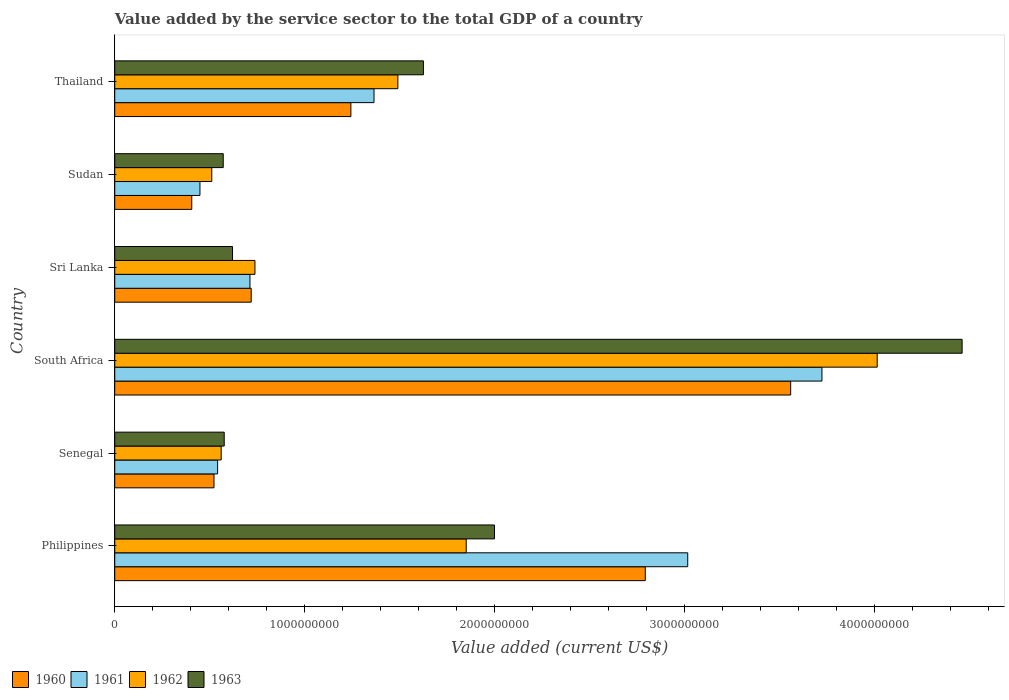Are the number of bars on each tick of the Y-axis equal?
Your answer should be very brief. Yes. How many bars are there on the 6th tick from the bottom?
Provide a short and direct response. 4. What is the value added by the service sector to the total GDP in 1962 in Philippines?
Ensure brevity in your answer.  1.85e+09. Across all countries, what is the maximum value added by the service sector to the total GDP in 1960?
Give a very brief answer. 3.56e+09. Across all countries, what is the minimum value added by the service sector to the total GDP in 1960?
Your answer should be compact. 4.06e+08. In which country was the value added by the service sector to the total GDP in 1962 maximum?
Provide a succinct answer. South Africa. In which country was the value added by the service sector to the total GDP in 1961 minimum?
Make the answer very short. Sudan. What is the total value added by the service sector to the total GDP in 1962 in the graph?
Offer a terse response. 9.17e+09. What is the difference between the value added by the service sector to the total GDP in 1960 in Philippines and that in Sri Lanka?
Ensure brevity in your answer.  2.08e+09. What is the difference between the value added by the service sector to the total GDP in 1962 in South Africa and the value added by the service sector to the total GDP in 1961 in Senegal?
Offer a very short reply. 3.47e+09. What is the average value added by the service sector to the total GDP in 1960 per country?
Keep it short and to the point. 1.54e+09. What is the difference between the value added by the service sector to the total GDP in 1961 and value added by the service sector to the total GDP in 1960 in South Africa?
Provide a short and direct response. 1.65e+08. In how many countries, is the value added by the service sector to the total GDP in 1963 greater than 200000000 US$?
Keep it short and to the point. 6. What is the ratio of the value added by the service sector to the total GDP in 1960 in Philippines to that in Sri Lanka?
Offer a very short reply. 3.89. Is the value added by the service sector to the total GDP in 1960 in South Africa less than that in Sri Lanka?
Offer a very short reply. No. Is the difference between the value added by the service sector to the total GDP in 1961 in South Africa and Sri Lanka greater than the difference between the value added by the service sector to the total GDP in 1960 in South Africa and Sri Lanka?
Offer a very short reply. Yes. What is the difference between the highest and the second highest value added by the service sector to the total GDP in 1963?
Keep it short and to the point. 2.46e+09. What is the difference between the highest and the lowest value added by the service sector to the total GDP in 1962?
Provide a succinct answer. 3.50e+09. In how many countries, is the value added by the service sector to the total GDP in 1960 greater than the average value added by the service sector to the total GDP in 1960 taken over all countries?
Ensure brevity in your answer.  2. How many legend labels are there?
Make the answer very short. 4. What is the title of the graph?
Your answer should be very brief. Value added by the service sector to the total GDP of a country. Does "1974" appear as one of the legend labels in the graph?
Provide a succinct answer. No. What is the label or title of the X-axis?
Your answer should be compact. Value added (current US$). What is the label or title of the Y-axis?
Offer a very short reply. Country. What is the Value added (current US$) in 1960 in Philippines?
Your answer should be compact. 2.79e+09. What is the Value added (current US$) of 1961 in Philippines?
Make the answer very short. 3.02e+09. What is the Value added (current US$) in 1962 in Philippines?
Your response must be concise. 1.85e+09. What is the Value added (current US$) in 1963 in Philippines?
Make the answer very short. 2.00e+09. What is the Value added (current US$) in 1960 in Senegal?
Your response must be concise. 5.23e+08. What is the Value added (current US$) of 1961 in Senegal?
Offer a terse response. 5.42e+08. What is the Value added (current US$) in 1962 in Senegal?
Your answer should be very brief. 5.60e+08. What is the Value added (current US$) in 1963 in Senegal?
Provide a short and direct response. 5.76e+08. What is the Value added (current US$) of 1960 in South Africa?
Ensure brevity in your answer.  3.56e+09. What is the Value added (current US$) in 1961 in South Africa?
Provide a succinct answer. 3.72e+09. What is the Value added (current US$) of 1962 in South Africa?
Offer a very short reply. 4.01e+09. What is the Value added (current US$) of 1963 in South Africa?
Keep it short and to the point. 4.46e+09. What is the Value added (current US$) in 1960 in Sri Lanka?
Your response must be concise. 7.18e+08. What is the Value added (current US$) in 1961 in Sri Lanka?
Your answer should be very brief. 7.12e+08. What is the Value added (current US$) in 1962 in Sri Lanka?
Keep it short and to the point. 7.38e+08. What is the Value added (current US$) of 1963 in Sri Lanka?
Your answer should be compact. 6.20e+08. What is the Value added (current US$) in 1960 in Sudan?
Offer a terse response. 4.06e+08. What is the Value added (current US$) in 1961 in Sudan?
Offer a terse response. 4.49e+08. What is the Value added (current US$) in 1962 in Sudan?
Your response must be concise. 5.11e+08. What is the Value added (current US$) in 1963 in Sudan?
Offer a terse response. 5.71e+08. What is the Value added (current US$) in 1960 in Thailand?
Ensure brevity in your answer.  1.24e+09. What is the Value added (current US$) in 1961 in Thailand?
Your response must be concise. 1.37e+09. What is the Value added (current US$) of 1962 in Thailand?
Provide a short and direct response. 1.49e+09. What is the Value added (current US$) of 1963 in Thailand?
Your answer should be very brief. 1.63e+09. Across all countries, what is the maximum Value added (current US$) of 1960?
Your answer should be compact. 3.56e+09. Across all countries, what is the maximum Value added (current US$) in 1961?
Your answer should be very brief. 3.72e+09. Across all countries, what is the maximum Value added (current US$) of 1962?
Keep it short and to the point. 4.01e+09. Across all countries, what is the maximum Value added (current US$) in 1963?
Provide a short and direct response. 4.46e+09. Across all countries, what is the minimum Value added (current US$) in 1960?
Give a very brief answer. 4.06e+08. Across all countries, what is the minimum Value added (current US$) of 1961?
Keep it short and to the point. 4.49e+08. Across all countries, what is the minimum Value added (current US$) in 1962?
Keep it short and to the point. 5.11e+08. Across all countries, what is the minimum Value added (current US$) in 1963?
Offer a terse response. 5.71e+08. What is the total Value added (current US$) of 1960 in the graph?
Provide a succinct answer. 9.24e+09. What is the total Value added (current US$) in 1961 in the graph?
Your answer should be compact. 9.81e+09. What is the total Value added (current US$) of 1962 in the graph?
Offer a terse response. 9.17e+09. What is the total Value added (current US$) of 1963 in the graph?
Ensure brevity in your answer.  9.85e+09. What is the difference between the Value added (current US$) in 1960 in Philippines and that in Senegal?
Keep it short and to the point. 2.27e+09. What is the difference between the Value added (current US$) in 1961 in Philippines and that in Senegal?
Offer a very short reply. 2.48e+09. What is the difference between the Value added (current US$) in 1962 in Philippines and that in Senegal?
Your answer should be compact. 1.29e+09. What is the difference between the Value added (current US$) of 1963 in Philippines and that in Senegal?
Offer a terse response. 1.42e+09. What is the difference between the Value added (current US$) of 1960 in Philippines and that in South Africa?
Your response must be concise. -7.66e+08. What is the difference between the Value added (current US$) of 1961 in Philippines and that in South Africa?
Your answer should be compact. -7.07e+08. What is the difference between the Value added (current US$) of 1962 in Philippines and that in South Africa?
Your answer should be compact. -2.16e+09. What is the difference between the Value added (current US$) of 1963 in Philippines and that in South Africa?
Your answer should be very brief. -2.46e+09. What is the difference between the Value added (current US$) in 1960 in Philippines and that in Sri Lanka?
Offer a very short reply. 2.08e+09. What is the difference between the Value added (current US$) of 1961 in Philippines and that in Sri Lanka?
Offer a terse response. 2.31e+09. What is the difference between the Value added (current US$) of 1962 in Philippines and that in Sri Lanka?
Your answer should be very brief. 1.11e+09. What is the difference between the Value added (current US$) of 1963 in Philippines and that in Sri Lanka?
Your answer should be very brief. 1.38e+09. What is the difference between the Value added (current US$) in 1960 in Philippines and that in Sudan?
Provide a short and direct response. 2.39e+09. What is the difference between the Value added (current US$) in 1961 in Philippines and that in Sudan?
Your response must be concise. 2.57e+09. What is the difference between the Value added (current US$) of 1962 in Philippines and that in Sudan?
Offer a very short reply. 1.34e+09. What is the difference between the Value added (current US$) of 1963 in Philippines and that in Sudan?
Provide a succinct answer. 1.43e+09. What is the difference between the Value added (current US$) in 1960 in Philippines and that in Thailand?
Offer a terse response. 1.55e+09. What is the difference between the Value added (current US$) of 1961 in Philippines and that in Thailand?
Provide a short and direct response. 1.65e+09. What is the difference between the Value added (current US$) in 1962 in Philippines and that in Thailand?
Provide a succinct answer. 3.60e+08. What is the difference between the Value added (current US$) of 1963 in Philippines and that in Thailand?
Offer a very short reply. 3.74e+08. What is the difference between the Value added (current US$) in 1960 in Senegal and that in South Africa?
Provide a short and direct response. -3.04e+09. What is the difference between the Value added (current US$) in 1961 in Senegal and that in South Africa?
Make the answer very short. -3.18e+09. What is the difference between the Value added (current US$) in 1962 in Senegal and that in South Africa?
Offer a terse response. -3.45e+09. What is the difference between the Value added (current US$) of 1963 in Senegal and that in South Africa?
Your response must be concise. -3.89e+09. What is the difference between the Value added (current US$) in 1960 in Senegal and that in Sri Lanka?
Keep it short and to the point. -1.96e+08. What is the difference between the Value added (current US$) in 1961 in Senegal and that in Sri Lanka?
Give a very brief answer. -1.70e+08. What is the difference between the Value added (current US$) of 1962 in Senegal and that in Sri Lanka?
Offer a very short reply. -1.78e+08. What is the difference between the Value added (current US$) in 1963 in Senegal and that in Sri Lanka?
Give a very brief answer. -4.38e+07. What is the difference between the Value added (current US$) of 1960 in Senegal and that in Sudan?
Give a very brief answer. 1.17e+08. What is the difference between the Value added (current US$) of 1961 in Senegal and that in Sudan?
Provide a short and direct response. 9.30e+07. What is the difference between the Value added (current US$) of 1962 in Senegal and that in Sudan?
Make the answer very short. 4.95e+07. What is the difference between the Value added (current US$) of 1963 in Senegal and that in Sudan?
Provide a short and direct response. 5.17e+06. What is the difference between the Value added (current US$) of 1960 in Senegal and that in Thailand?
Your answer should be compact. -7.21e+08. What is the difference between the Value added (current US$) of 1961 in Senegal and that in Thailand?
Ensure brevity in your answer.  -8.24e+08. What is the difference between the Value added (current US$) in 1962 in Senegal and that in Thailand?
Ensure brevity in your answer.  -9.30e+08. What is the difference between the Value added (current US$) in 1963 in Senegal and that in Thailand?
Provide a succinct answer. -1.05e+09. What is the difference between the Value added (current US$) in 1960 in South Africa and that in Sri Lanka?
Provide a short and direct response. 2.84e+09. What is the difference between the Value added (current US$) in 1961 in South Africa and that in Sri Lanka?
Your answer should be compact. 3.01e+09. What is the difference between the Value added (current US$) in 1962 in South Africa and that in Sri Lanka?
Your response must be concise. 3.28e+09. What is the difference between the Value added (current US$) of 1963 in South Africa and that in Sri Lanka?
Your answer should be very brief. 3.84e+09. What is the difference between the Value added (current US$) of 1960 in South Africa and that in Sudan?
Ensure brevity in your answer.  3.15e+09. What is the difference between the Value added (current US$) in 1961 in South Africa and that in Sudan?
Provide a succinct answer. 3.28e+09. What is the difference between the Value added (current US$) in 1962 in South Africa and that in Sudan?
Offer a terse response. 3.50e+09. What is the difference between the Value added (current US$) of 1963 in South Africa and that in Sudan?
Your answer should be compact. 3.89e+09. What is the difference between the Value added (current US$) in 1960 in South Africa and that in Thailand?
Ensure brevity in your answer.  2.32e+09. What is the difference between the Value added (current US$) of 1961 in South Africa and that in Thailand?
Ensure brevity in your answer.  2.36e+09. What is the difference between the Value added (current US$) in 1962 in South Africa and that in Thailand?
Give a very brief answer. 2.52e+09. What is the difference between the Value added (current US$) in 1963 in South Africa and that in Thailand?
Keep it short and to the point. 2.84e+09. What is the difference between the Value added (current US$) of 1960 in Sri Lanka and that in Sudan?
Offer a very short reply. 3.13e+08. What is the difference between the Value added (current US$) in 1961 in Sri Lanka and that in Sudan?
Your answer should be compact. 2.63e+08. What is the difference between the Value added (current US$) in 1962 in Sri Lanka and that in Sudan?
Your answer should be very brief. 2.27e+08. What is the difference between the Value added (current US$) of 1963 in Sri Lanka and that in Sudan?
Make the answer very short. 4.89e+07. What is the difference between the Value added (current US$) in 1960 in Sri Lanka and that in Thailand?
Keep it short and to the point. -5.25e+08. What is the difference between the Value added (current US$) in 1961 in Sri Lanka and that in Thailand?
Ensure brevity in your answer.  -6.53e+08. What is the difference between the Value added (current US$) in 1962 in Sri Lanka and that in Thailand?
Provide a succinct answer. -7.53e+08. What is the difference between the Value added (current US$) in 1963 in Sri Lanka and that in Thailand?
Your answer should be very brief. -1.01e+09. What is the difference between the Value added (current US$) of 1960 in Sudan and that in Thailand?
Offer a terse response. -8.38e+08. What is the difference between the Value added (current US$) in 1961 in Sudan and that in Thailand?
Your answer should be compact. -9.17e+08. What is the difference between the Value added (current US$) of 1962 in Sudan and that in Thailand?
Offer a very short reply. -9.80e+08. What is the difference between the Value added (current US$) in 1963 in Sudan and that in Thailand?
Provide a short and direct response. -1.05e+09. What is the difference between the Value added (current US$) of 1960 in Philippines and the Value added (current US$) of 1961 in Senegal?
Your answer should be very brief. 2.25e+09. What is the difference between the Value added (current US$) of 1960 in Philippines and the Value added (current US$) of 1962 in Senegal?
Ensure brevity in your answer.  2.23e+09. What is the difference between the Value added (current US$) in 1960 in Philippines and the Value added (current US$) in 1963 in Senegal?
Provide a succinct answer. 2.22e+09. What is the difference between the Value added (current US$) in 1961 in Philippines and the Value added (current US$) in 1962 in Senegal?
Offer a very short reply. 2.46e+09. What is the difference between the Value added (current US$) in 1961 in Philippines and the Value added (current US$) in 1963 in Senegal?
Provide a short and direct response. 2.44e+09. What is the difference between the Value added (current US$) of 1962 in Philippines and the Value added (current US$) of 1963 in Senegal?
Make the answer very short. 1.27e+09. What is the difference between the Value added (current US$) of 1960 in Philippines and the Value added (current US$) of 1961 in South Africa?
Provide a short and direct response. -9.30e+08. What is the difference between the Value added (current US$) in 1960 in Philippines and the Value added (current US$) in 1962 in South Africa?
Offer a terse response. -1.22e+09. What is the difference between the Value added (current US$) in 1960 in Philippines and the Value added (current US$) in 1963 in South Africa?
Offer a very short reply. -1.67e+09. What is the difference between the Value added (current US$) in 1961 in Philippines and the Value added (current US$) in 1962 in South Africa?
Offer a very short reply. -9.98e+08. What is the difference between the Value added (current US$) in 1961 in Philippines and the Value added (current US$) in 1963 in South Africa?
Offer a terse response. -1.44e+09. What is the difference between the Value added (current US$) in 1962 in Philippines and the Value added (current US$) in 1963 in South Africa?
Your answer should be compact. -2.61e+09. What is the difference between the Value added (current US$) of 1960 in Philippines and the Value added (current US$) of 1961 in Sri Lanka?
Your response must be concise. 2.08e+09. What is the difference between the Value added (current US$) in 1960 in Philippines and the Value added (current US$) in 1962 in Sri Lanka?
Your response must be concise. 2.06e+09. What is the difference between the Value added (current US$) of 1960 in Philippines and the Value added (current US$) of 1963 in Sri Lanka?
Make the answer very short. 2.17e+09. What is the difference between the Value added (current US$) in 1961 in Philippines and the Value added (current US$) in 1962 in Sri Lanka?
Provide a short and direct response. 2.28e+09. What is the difference between the Value added (current US$) of 1961 in Philippines and the Value added (current US$) of 1963 in Sri Lanka?
Offer a terse response. 2.40e+09. What is the difference between the Value added (current US$) of 1962 in Philippines and the Value added (current US$) of 1963 in Sri Lanka?
Keep it short and to the point. 1.23e+09. What is the difference between the Value added (current US$) of 1960 in Philippines and the Value added (current US$) of 1961 in Sudan?
Offer a terse response. 2.35e+09. What is the difference between the Value added (current US$) in 1960 in Philippines and the Value added (current US$) in 1962 in Sudan?
Provide a short and direct response. 2.28e+09. What is the difference between the Value added (current US$) in 1960 in Philippines and the Value added (current US$) in 1963 in Sudan?
Give a very brief answer. 2.22e+09. What is the difference between the Value added (current US$) in 1961 in Philippines and the Value added (current US$) in 1962 in Sudan?
Keep it short and to the point. 2.51e+09. What is the difference between the Value added (current US$) of 1961 in Philippines and the Value added (current US$) of 1963 in Sudan?
Ensure brevity in your answer.  2.45e+09. What is the difference between the Value added (current US$) of 1962 in Philippines and the Value added (current US$) of 1963 in Sudan?
Offer a very short reply. 1.28e+09. What is the difference between the Value added (current US$) in 1960 in Philippines and the Value added (current US$) in 1961 in Thailand?
Give a very brief answer. 1.43e+09. What is the difference between the Value added (current US$) in 1960 in Philippines and the Value added (current US$) in 1962 in Thailand?
Offer a very short reply. 1.30e+09. What is the difference between the Value added (current US$) in 1960 in Philippines and the Value added (current US$) in 1963 in Thailand?
Give a very brief answer. 1.17e+09. What is the difference between the Value added (current US$) in 1961 in Philippines and the Value added (current US$) in 1962 in Thailand?
Provide a short and direct response. 1.53e+09. What is the difference between the Value added (current US$) of 1961 in Philippines and the Value added (current US$) of 1963 in Thailand?
Make the answer very short. 1.39e+09. What is the difference between the Value added (current US$) of 1962 in Philippines and the Value added (current US$) of 1963 in Thailand?
Ensure brevity in your answer.  2.25e+08. What is the difference between the Value added (current US$) in 1960 in Senegal and the Value added (current US$) in 1961 in South Africa?
Provide a succinct answer. -3.20e+09. What is the difference between the Value added (current US$) of 1960 in Senegal and the Value added (current US$) of 1962 in South Africa?
Offer a terse response. -3.49e+09. What is the difference between the Value added (current US$) of 1960 in Senegal and the Value added (current US$) of 1963 in South Africa?
Your answer should be compact. -3.94e+09. What is the difference between the Value added (current US$) of 1961 in Senegal and the Value added (current US$) of 1962 in South Africa?
Provide a short and direct response. -3.47e+09. What is the difference between the Value added (current US$) in 1961 in Senegal and the Value added (current US$) in 1963 in South Africa?
Provide a succinct answer. -3.92e+09. What is the difference between the Value added (current US$) in 1962 in Senegal and the Value added (current US$) in 1963 in South Africa?
Give a very brief answer. -3.90e+09. What is the difference between the Value added (current US$) in 1960 in Senegal and the Value added (current US$) in 1961 in Sri Lanka?
Keep it short and to the point. -1.89e+08. What is the difference between the Value added (current US$) in 1960 in Senegal and the Value added (current US$) in 1962 in Sri Lanka?
Give a very brief answer. -2.16e+08. What is the difference between the Value added (current US$) of 1960 in Senegal and the Value added (current US$) of 1963 in Sri Lanka?
Your answer should be very brief. -9.75e+07. What is the difference between the Value added (current US$) in 1961 in Senegal and the Value added (current US$) in 1962 in Sri Lanka?
Give a very brief answer. -1.97e+08. What is the difference between the Value added (current US$) in 1961 in Senegal and the Value added (current US$) in 1963 in Sri Lanka?
Provide a succinct answer. -7.85e+07. What is the difference between the Value added (current US$) of 1962 in Senegal and the Value added (current US$) of 1963 in Sri Lanka?
Offer a terse response. -5.98e+07. What is the difference between the Value added (current US$) in 1960 in Senegal and the Value added (current US$) in 1961 in Sudan?
Make the answer very short. 7.40e+07. What is the difference between the Value added (current US$) in 1960 in Senegal and the Value added (current US$) in 1962 in Sudan?
Offer a terse response. 1.17e+07. What is the difference between the Value added (current US$) of 1960 in Senegal and the Value added (current US$) of 1963 in Sudan?
Make the answer very short. -4.86e+07. What is the difference between the Value added (current US$) in 1961 in Senegal and the Value added (current US$) in 1962 in Sudan?
Your answer should be very brief. 3.07e+07. What is the difference between the Value added (current US$) of 1961 in Senegal and the Value added (current US$) of 1963 in Sudan?
Give a very brief answer. -2.96e+07. What is the difference between the Value added (current US$) in 1962 in Senegal and the Value added (current US$) in 1963 in Sudan?
Provide a succinct answer. -1.08e+07. What is the difference between the Value added (current US$) of 1960 in Senegal and the Value added (current US$) of 1961 in Thailand?
Provide a succinct answer. -8.43e+08. What is the difference between the Value added (current US$) in 1960 in Senegal and the Value added (current US$) in 1962 in Thailand?
Your response must be concise. -9.68e+08. What is the difference between the Value added (current US$) of 1960 in Senegal and the Value added (current US$) of 1963 in Thailand?
Make the answer very short. -1.10e+09. What is the difference between the Value added (current US$) of 1961 in Senegal and the Value added (current US$) of 1962 in Thailand?
Your answer should be compact. -9.49e+08. What is the difference between the Value added (current US$) of 1961 in Senegal and the Value added (current US$) of 1963 in Thailand?
Offer a terse response. -1.08e+09. What is the difference between the Value added (current US$) of 1962 in Senegal and the Value added (current US$) of 1963 in Thailand?
Give a very brief answer. -1.06e+09. What is the difference between the Value added (current US$) of 1960 in South Africa and the Value added (current US$) of 1961 in Sri Lanka?
Offer a terse response. 2.85e+09. What is the difference between the Value added (current US$) in 1960 in South Africa and the Value added (current US$) in 1962 in Sri Lanka?
Your answer should be very brief. 2.82e+09. What is the difference between the Value added (current US$) in 1960 in South Africa and the Value added (current US$) in 1963 in Sri Lanka?
Your answer should be very brief. 2.94e+09. What is the difference between the Value added (current US$) of 1961 in South Africa and the Value added (current US$) of 1962 in Sri Lanka?
Offer a terse response. 2.99e+09. What is the difference between the Value added (current US$) in 1961 in South Africa and the Value added (current US$) in 1963 in Sri Lanka?
Your answer should be very brief. 3.10e+09. What is the difference between the Value added (current US$) in 1962 in South Africa and the Value added (current US$) in 1963 in Sri Lanka?
Provide a succinct answer. 3.39e+09. What is the difference between the Value added (current US$) in 1960 in South Africa and the Value added (current US$) in 1961 in Sudan?
Ensure brevity in your answer.  3.11e+09. What is the difference between the Value added (current US$) in 1960 in South Africa and the Value added (current US$) in 1962 in Sudan?
Offer a very short reply. 3.05e+09. What is the difference between the Value added (current US$) in 1960 in South Africa and the Value added (current US$) in 1963 in Sudan?
Offer a very short reply. 2.99e+09. What is the difference between the Value added (current US$) of 1961 in South Africa and the Value added (current US$) of 1962 in Sudan?
Provide a short and direct response. 3.21e+09. What is the difference between the Value added (current US$) of 1961 in South Africa and the Value added (current US$) of 1963 in Sudan?
Provide a succinct answer. 3.15e+09. What is the difference between the Value added (current US$) in 1962 in South Africa and the Value added (current US$) in 1963 in Sudan?
Your response must be concise. 3.44e+09. What is the difference between the Value added (current US$) of 1960 in South Africa and the Value added (current US$) of 1961 in Thailand?
Ensure brevity in your answer.  2.19e+09. What is the difference between the Value added (current US$) in 1960 in South Africa and the Value added (current US$) in 1962 in Thailand?
Give a very brief answer. 2.07e+09. What is the difference between the Value added (current US$) of 1960 in South Africa and the Value added (current US$) of 1963 in Thailand?
Give a very brief answer. 1.93e+09. What is the difference between the Value added (current US$) of 1961 in South Africa and the Value added (current US$) of 1962 in Thailand?
Ensure brevity in your answer.  2.23e+09. What is the difference between the Value added (current US$) in 1961 in South Africa and the Value added (current US$) in 1963 in Thailand?
Your response must be concise. 2.10e+09. What is the difference between the Value added (current US$) of 1962 in South Africa and the Value added (current US$) of 1963 in Thailand?
Ensure brevity in your answer.  2.39e+09. What is the difference between the Value added (current US$) in 1960 in Sri Lanka and the Value added (current US$) in 1961 in Sudan?
Offer a terse response. 2.70e+08. What is the difference between the Value added (current US$) of 1960 in Sri Lanka and the Value added (current US$) of 1962 in Sudan?
Make the answer very short. 2.08e+08. What is the difference between the Value added (current US$) in 1960 in Sri Lanka and the Value added (current US$) in 1963 in Sudan?
Provide a succinct answer. 1.47e+08. What is the difference between the Value added (current US$) of 1961 in Sri Lanka and the Value added (current US$) of 1962 in Sudan?
Provide a succinct answer. 2.01e+08. What is the difference between the Value added (current US$) in 1961 in Sri Lanka and the Value added (current US$) in 1963 in Sudan?
Provide a short and direct response. 1.41e+08. What is the difference between the Value added (current US$) in 1962 in Sri Lanka and the Value added (current US$) in 1963 in Sudan?
Your answer should be compact. 1.67e+08. What is the difference between the Value added (current US$) in 1960 in Sri Lanka and the Value added (current US$) in 1961 in Thailand?
Keep it short and to the point. -6.47e+08. What is the difference between the Value added (current US$) of 1960 in Sri Lanka and the Value added (current US$) of 1962 in Thailand?
Offer a very short reply. -7.72e+08. What is the difference between the Value added (current US$) of 1960 in Sri Lanka and the Value added (current US$) of 1963 in Thailand?
Your answer should be very brief. -9.07e+08. What is the difference between the Value added (current US$) in 1961 in Sri Lanka and the Value added (current US$) in 1962 in Thailand?
Make the answer very short. -7.79e+08. What is the difference between the Value added (current US$) of 1961 in Sri Lanka and the Value added (current US$) of 1963 in Thailand?
Offer a terse response. -9.13e+08. What is the difference between the Value added (current US$) of 1962 in Sri Lanka and the Value added (current US$) of 1963 in Thailand?
Give a very brief answer. -8.87e+08. What is the difference between the Value added (current US$) in 1960 in Sudan and the Value added (current US$) in 1961 in Thailand?
Provide a short and direct response. -9.60e+08. What is the difference between the Value added (current US$) of 1960 in Sudan and the Value added (current US$) of 1962 in Thailand?
Make the answer very short. -1.09e+09. What is the difference between the Value added (current US$) of 1960 in Sudan and the Value added (current US$) of 1963 in Thailand?
Provide a short and direct response. -1.22e+09. What is the difference between the Value added (current US$) in 1961 in Sudan and the Value added (current US$) in 1962 in Thailand?
Make the answer very short. -1.04e+09. What is the difference between the Value added (current US$) of 1961 in Sudan and the Value added (current US$) of 1963 in Thailand?
Provide a succinct answer. -1.18e+09. What is the difference between the Value added (current US$) in 1962 in Sudan and the Value added (current US$) in 1963 in Thailand?
Your response must be concise. -1.11e+09. What is the average Value added (current US$) of 1960 per country?
Offer a terse response. 1.54e+09. What is the average Value added (current US$) of 1961 per country?
Provide a succinct answer. 1.63e+09. What is the average Value added (current US$) in 1962 per country?
Make the answer very short. 1.53e+09. What is the average Value added (current US$) of 1963 per country?
Your answer should be compact. 1.64e+09. What is the difference between the Value added (current US$) in 1960 and Value added (current US$) in 1961 in Philippines?
Offer a terse response. -2.24e+08. What is the difference between the Value added (current US$) of 1960 and Value added (current US$) of 1962 in Philippines?
Offer a terse response. 9.43e+08. What is the difference between the Value added (current US$) of 1960 and Value added (current US$) of 1963 in Philippines?
Ensure brevity in your answer.  7.94e+08. What is the difference between the Value added (current US$) in 1961 and Value added (current US$) in 1962 in Philippines?
Make the answer very short. 1.17e+09. What is the difference between the Value added (current US$) of 1961 and Value added (current US$) of 1963 in Philippines?
Your answer should be very brief. 1.02e+09. What is the difference between the Value added (current US$) in 1962 and Value added (current US$) in 1963 in Philippines?
Offer a very short reply. -1.49e+08. What is the difference between the Value added (current US$) of 1960 and Value added (current US$) of 1961 in Senegal?
Keep it short and to the point. -1.90e+07. What is the difference between the Value added (current US$) of 1960 and Value added (current US$) of 1962 in Senegal?
Your answer should be compact. -3.77e+07. What is the difference between the Value added (current US$) in 1960 and Value added (current US$) in 1963 in Senegal?
Provide a succinct answer. -5.38e+07. What is the difference between the Value added (current US$) in 1961 and Value added (current US$) in 1962 in Senegal?
Ensure brevity in your answer.  -1.87e+07. What is the difference between the Value added (current US$) of 1961 and Value added (current US$) of 1963 in Senegal?
Offer a terse response. -3.48e+07. What is the difference between the Value added (current US$) in 1962 and Value added (current US$) in 1963 in Senegal?
Offer a very short reply. -1.60e+07. What is the difference between the Value added (current US$) of 1960 and Value added (current US$) of 1961 in South Africa?
Provide a succinct answer. -1.65e+08. What is the difference between the Value added (current US$) in 1960 and Value added (current US$) in 1962 in South Africa?
Ensure brevity in your answer.  -4.56e+08. What is the difference between the Value added (current US$) in 1960 and Value added (current US$) in 1963 in South Africa?
Your answer should be very brief. -9.03e+08. What is the difference between the Value added (current US$) in 1961 and Value added (current US$) in 1962 in South Africa?
Provide a short and direct response. -2.91e+08. What is the difference between the Value added (current US$) of 1961 and Value added (current US$) of 1963 in South Africa?
Your response must be concise. -7.38e+08. What is the difference between the Value added (current US$) in 1962 and Value added (current US$) in 1963 in South Africa?
Your answer should be very brief. -4.47e+08. What is the difference between the Value added (current US$) in 1960 and Value added (current US$) in 1961 in Sri Lanka?
Your answer should be compact. 6.51e+06. What is the difference between the Value added (current US$) of 1960 and Value added (current US$) of 1962 in Sri Lanka?
Your answer should be compact. -1.98e+07. What is the difference between the Value added (current US$) in 1960 and Value added (current US$) in 1963 in Sri Lanka?
Provide a short and direct response. 9.83e+07. What is the difference between the Value added (current US$) in 1961 and Value added (current US$) in 1962 in Sri Lanka?
Provide a short and direct response. -2.63e+07. What is the difference between the Value added (current US$) in 1961 and Value added (current US$) in 1963 in Sri Lanka?
Your response must be concise. 9.18e+07. What is the difference between the Value added (current US$) in 1962 and Value added (current US$) in 1963 in Sri Lanka?
Give a very brief answer. 1.18e+08. What is the difference between the Value added (current US$) of 1960 and Value added (current US$) of 1961 in Sudan?
Provide a succinct answer. -4.31e+07. What is the difference between the Value added (current US$) in 1960 and Value added (current US$) in 1962 in Sudan?
Offer a terse response. -1.05e+08. What is the difference between the Value added (current US$) in 1960 and Value added (current US$) in 1963 in Sudan?
Your response must be concise. -1.66e+08. What is the difference between the Value added (current US$) in 1961 and Value added (current US$) in 1962 in Sudan?
Your answer should be very brief. -6.23e+07. What is the difference between the Value added (current US$) in 1961 and Value added (current US$) in 1963 in Sudan?
Your answer should be compact. -1.23e+08. What is the difference between the Value added (current US$) of 1962 and Value added (current US$) of 1963 in Sudan?
Your response must be concise. -6.03e+07. What is the difference between the Value added (current US$) in 1960 and Value added (current US$) in 1961 in Thailand?
Keep it short and to the point. -1.22e+08. What is the difference between the Value added (current US$) in 1960 and Value added (current US$) in 1962 in Thailand?
Offer a very short reply. -2.47e+08. What is the difference between the Value added (current US$) of 1960 and Value added (current US$) of 1963 in Thailand?
Keep it short and to the point. -3.82e+08. What is the difference between the Value added (current US$) of 1961 and Value added (current US$) of 1962 in Thailand?
Give a very brief answer. -1.26e+08. What is the difference between the Value added (current US$) of 1961 and Value added (current US$) of 1963 in Thailand?
Ensure brevity in your answer.  -2.60e+08. What is the difference between the Value added (current US$) in 1962 and Value added (current US$) in 1963 in Thailand?
Your answer should be compact. -1.35e+08. What is the ratio of the Value added (current US$) in 1960 in Philippines to that in Senegal?
Your answer should be compact. 5.35. What is the ratio of the Value added (current US$) of 1961 in Philippines to that in Senegal?
Offer a very short reply. 5.57. What is the ratio of the Value added (current US$) of 1962 in Philippines to that in Senegal?
Provide a short and direct response. 3.3. What is the ratio of the Value added (current US$) in 1963 in Philippines to that in Senegal?
Make the answer very short. 3.47. What is the ratio of the Value added (current US$) of 1960 in Philippines to that in South Africa?
Offer a very short reply. 0.78. What is the ratio of the Value added (current US$) of 1961 in Philippines to that in South Africa?
Offer a very short reply. 0.81. What is the ratio of the Value added (current US$) of 1962 in Philippines to that in South Africa?
Your response must be concise. 0.46. What is the ratio of the Value added (current US$) in 1963 in Philippines to that in South Africa?
Give a very brief answer. 0.45. What is the ratio of the Value added (current US$) in 1960 in Philippines to that in Sri Lanka?
Ensure brevity in your answer.  3.89. What is the ratio of the Value added (current US$) in 1961 in Philippines to that in Sri Lanka?
Your response must be concise. 4.24. What is the ratio of the Value added (current US$) in 1962 in Philippines to that in Sri Lanka?
Offer a terse response. 2.51. What is the ratio of the Value added (current US$) in 1963 in Philippines to that in Sri Lanka?
Give a very brief answer. 3.22. What is the ratio of the Value added (current US$) in 1960 in Philippines to that in Sudan?
Make the answer very short. 6.89. What is the ratio of the Value added (current US$) of 1961 in Philippines to that in Sudan?
Make the answer very short. 6.73. What is the ratio of the Value added (current US$) of 1962 in Philippines to that in Sudan?
Your answer should be very brief. 3.62. What is the ratio of the Value added (current US$) in 1963 in Philippines to that in Sudan?
Your response must be concise. 3.5. What is the ratio of the Value added (current US$) in 1960 in Philippines to that in Thailand?
Keep it short and to the point. 2.25. What is the ratio of the Value added (current US$) of 1961 in Philippines to that in Thailand?
Your response must be concise. 2.21. What is the ratio of the Value added (current US$) of 1962 in Philippines to that in Thailand?
Make the answer very short. 1.24. What is the ratio of the Value added (current US$) in 1963 in Philippines to that in Thailand?
Your answer should be compact. 1.23. What is the ratio of the Value added (current US$) of 1960 in Senegal to that in South Africa?
Make the answer very short. 0.15. What is the ratio of the Value added (current US$) of 1961 in Senegal to that in South Africa?
Your answer should be very brief. 0.15. What is the ratio of the Value added (current US$) in 1962 in Senegal to that in South Africa?
Your answer should be compact. 0.14. What is the ratio of the Value added (current US$) in 1963 in Senegal to that in South Africa?
Provide a succinct answer. 0.13. What is the ratio of the Value added (current US$) in 1960 in Senegal to that in Sri Lanka?
Your answer should be very brief. 0.73. What is the ratio of the Value added (current US$) in 1961 in Senegal to that in Sri Lanka?
Ensure brevity in your answer.  0.76. What is the ratio of the Value added (current US$) in 1962 in Senegal to that in Sri Lanka?
Your answer should be compact. 0.76. What is the ratio of the Value added (current US$) in 1963 in Senegal to that in Sri Lanka?
Provide a succinct answer. 0.93. What is the ratio of the Value added (current US$) in 1960 in Senegal to that in Sudan?
Give a very brief answer. 1.29. What is the ratio of the Value added (current US$) of 1961 in Senegal to that in Sudan?
Keep it short and to the point. 1.21. What is the ratio of the Value added (current US$) in 1962 in Senegal to that in Sudan?
Your response must be concise. 1.1. What is the ratio of the Value added (current US$) in 1960 in Senegal to that in Thailand?
Ensure brevity in your answer.  0.42. What is the ratio of the Value added (current US$) in 1961 in Senegal to that in Thailand?
Make the answer very short. 0.4. What is the ratio of the Value added (current US$) of 1962 in Senegal to that in Thailand?
Make the answer very short. 0.38. What is the ratio of the Value added (current US$) in 1963 in Senegal to that in Thailand?
Provide a succinct answer. 0.35. What is the ratio of the Value added (current US$) in 1960 in South Africa to that in Sri Lanka?
Your answer should be compact. 4.95. What is the ratio of the Value added (current US$) of 1961 in South Africa to that in Sri Lanka?
Offer a very short reply. 5.23. What is the ratio of the Value added (current US$) in 1962 in South Africa to that in Sri Lanka?
Provide a short and direct response. 5.44. What is the ratio of the Value added (current US$) of 1963 in South Africa to that in Sri Lanka?
Provide a succinct answer. 7.19. What is the ratio of the Value added (current US$) in 1960 in South Africa to that in Sudan?
Ensure brevity in your answer.  8.78. What is the ratio of the Value added (current US$) in 1961 in South Africa to that in Sudan?
Provide a succinct answer. 8.3. What is the ratio of the Value added (current US$) in 1962 in South Africa to that in Sudan?
Provide a succinct answer. 7.86. What is the ratio of the Value added (current US$) in 1963 in South Africa to that in Sudan?
Your answer should be compact. 7.81. What is the ratio of the Value added (current US$) of 1960 in South Africa to that in Thailand?
Offer a terse response. 2.86. What is the ratio of the Value added (current US$) of 1961 in South Africa to that in Thailand?
Make the answer very short. 2.73. What is the ratio of the Value added (current US$) in 1962 in South Africa to that in Thailand?
Provide a short and direct response. 2.69. What is the ratio of the Value added (current US$) in 1963 in South Africa to that in Thailand?
Your answer should be very brief. 2.75. What is the ratio of the Value added (current US$) in 1960 in Sri Lanka to that in Sudan?
Provide a short and direct response. 1.77. What is the ratio of the Value added (current US$) in 1961 in Sri Lanka to that in Sudan?
Make the answer very short. 1.59. What is the ratio of the Value added (current US$) of 1962 in Sri Lanka to that in Sudan?
Your response must be concise. 1.45. What is the ratio of the Value added (current US$) in 1963 in Sri Lanka to that in Sudan?
Make the answer very short. 1.09. What is the ratio of the Value added (current US$) of 1960 in Sri Lanka to that in Thailand?
Provide a short and direct response. 0.58. What is the ratio of the Value added (current US$) of 1961 in Sri Lanka to that in Thailand?
Your answer should be very brief. 0.52. What is the ratio of the Value added (current US$) in 1962 in Sri Lanka to that in Thailand?
Provide a succinct answer. 0.5. What is the ratio of the Value added (current US$) of 1963 in Sri Lanka to that in Thailand?
Your response must be concise. 0.38. What is the ratio of the Value added (current US$) in 1960 in Sudan to that in Thailand?
Make the answer very short. 0.33. What is the ratio of the Value added (current US$) of 1961 in Sudan to that in Thailand?
Your answer should be compact. 0.33. What is the ratio of the Value added (current US$) of 1962 in Sudan to that in Thailand?
Ensure brevity in your answer.  0.34. What is the ratio of the Value added (current US$) in 1963 in Sudan to that in Thailand?
Your answer should be compact. 0.35. What is the difference between the highest and the second highest Value added (current US$) in 1960?
Your answer should be very brief. 7.66e+08. What is the difference between the highest and the second highest Value added (current US$) in 1961?
Offer a very short reply. 7.07e+08. What is the difference between the highest and the second highest Value added (current US$) of 1962?
Provide a succinct answer. 2.16e+09. What is the difference between the highest and the second highest Value added (current US$) in 1963?
Offer a very short reply. 2.46e+09. What is the difference between the highest and the lowest Value added (current US$) in 1960?
Ensure brevity in your answer.  3.15e+09. What is the difference between the highest and the lowest Value added (current US$) of 1961?
Your response must be concise. 3.28e+09. What is the difference between the highest and the lowest Value added (current US$) of 1962?
Provide a succinct answer. 3.50e+09. What is the difference between the highest and the lowest Value added (current US$) of 1963?
Your response must be concise. 3.89e+09. 